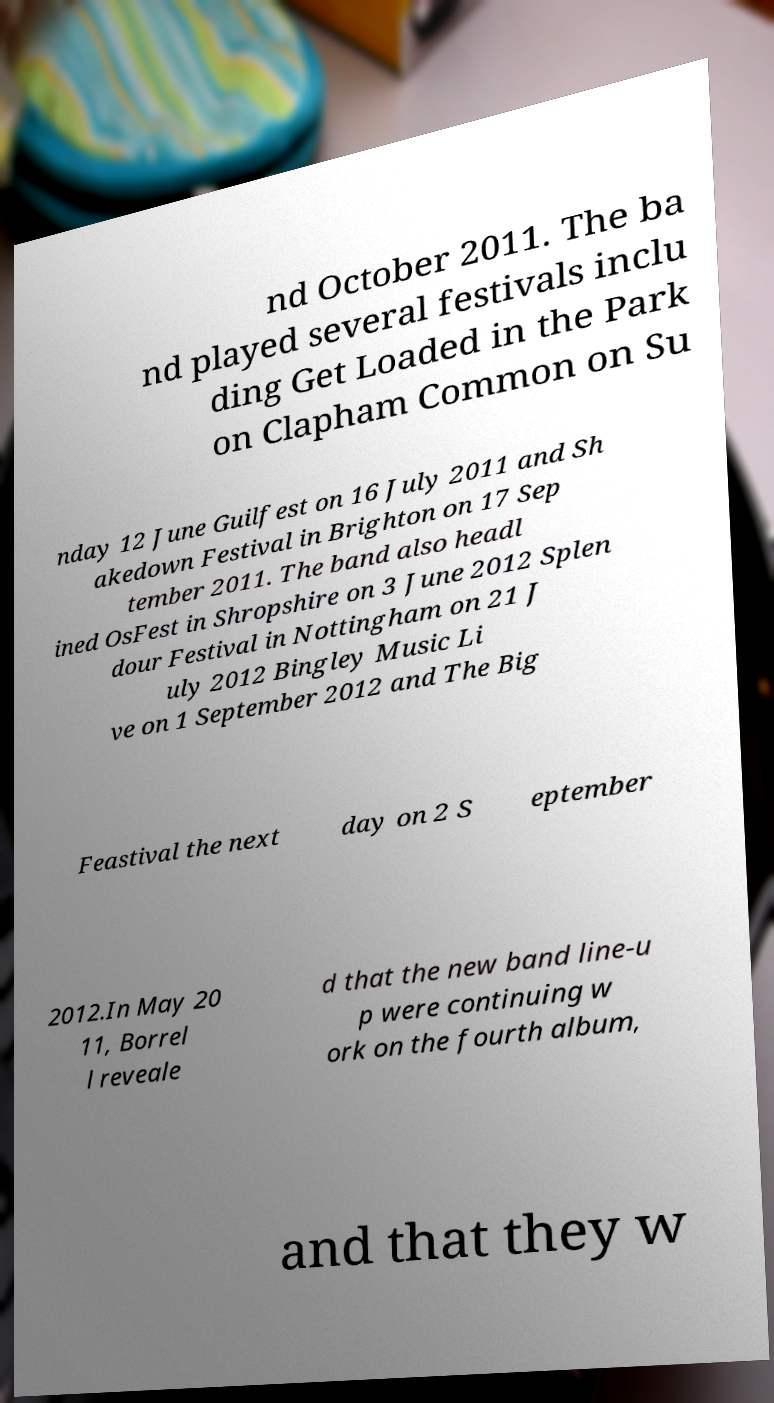Can you accurately transcribe the text from the provided image for me? nd October 2011. The ba nd played several festivals inclu ding Get Loaded in the Park on Clapham Common on Su nday 12 June Guilfest on 16 July 2011 and Sh akedown Festival in Brighton on 17 Sep tember 2011. The band also headl ined OsFest in Shropshire on 3 June 2012 Splen dour Festival in Nottingham on 21 J uly 2012 Bingley Music Li ve on 1 September 2012 and The Big Feastival the next day on 2 S eptember 2012.In May 20 11, Borrel l reveale d that the new band line-u p were continuing w ork on the fourth album, and that they w 